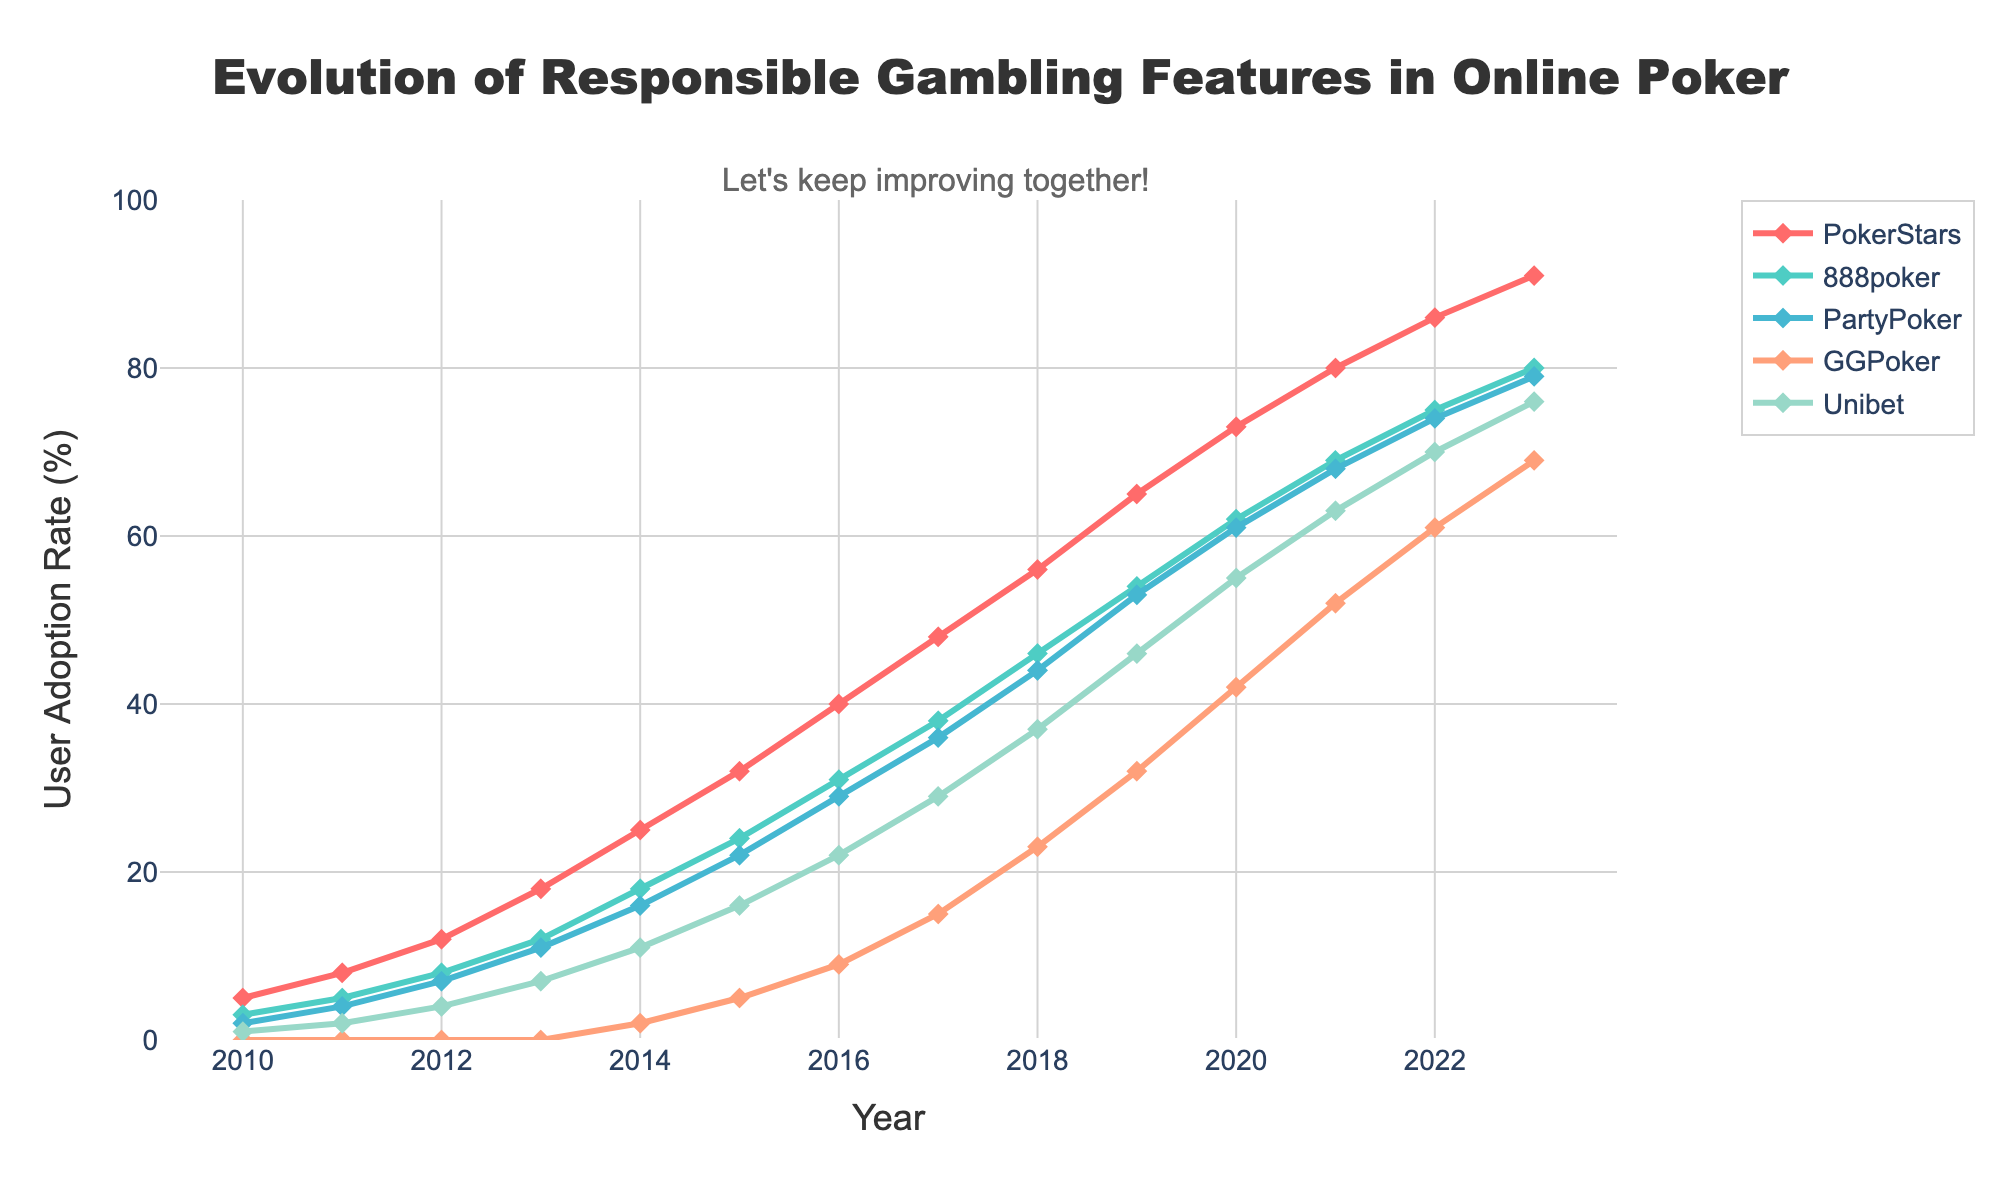What is the adoption rate of responsible gambling features for PokerStars in 2017? Look at the line corresponding to PokerStars and check the y-axis value at the year 2017.
Answer: 48 Which poker site had the lowest adoption rate in 2010? Check the y-axis values for each poker site at the year 2010 and identify the lowest value.
Answer: GGPoker By how much did the user adoption rate for Unibet increase from 2012 to 2015? Find the y-axis value for Unibet in 2015 and subtract the y-axis value for Unibet in 2012.
Answer: 12 Which poker site had the highest increase in user adoption rate from 2010 to 2023? Calculate the difference in user adoption rate for each poker site between 2010 and 2023 and identify the highest value.
Answer: PokerStars Between 2018 and 2020, which poker site saw the greatest increase in adoption rate of responsible gambling features? Calculate the difference in the y-axis values between 2018 and 2020 for each poker site and identify the greatest increase.
Answer: GGPoker What is the average user adoption rate for all poker sites in 2023? Sum the user adoption rates for all poker sites in 2023 and divide by the number of poker sites.
Answer: 79 Which poker site had the smallest change in adoption rate from 2019 to 2023? Calculate the difference in the adoption rate for each poker site between 2019 and 2023 and find the smallest change.
Answer: 888poker In which year did PokerStars' adoption rate of responsible gambling features surpass 50%? Locate the year when the y-axis value for PokerStars first exceeds 50%.
Answer: 2018 What is the average annual increase in adoption rate for PartyPoker from 2010 to 2023? Calculate the total increase in adoption rate for PartyPoker from 2010 to 2023 and divide by the number of years (2023-2010).
Answer: 5.92 